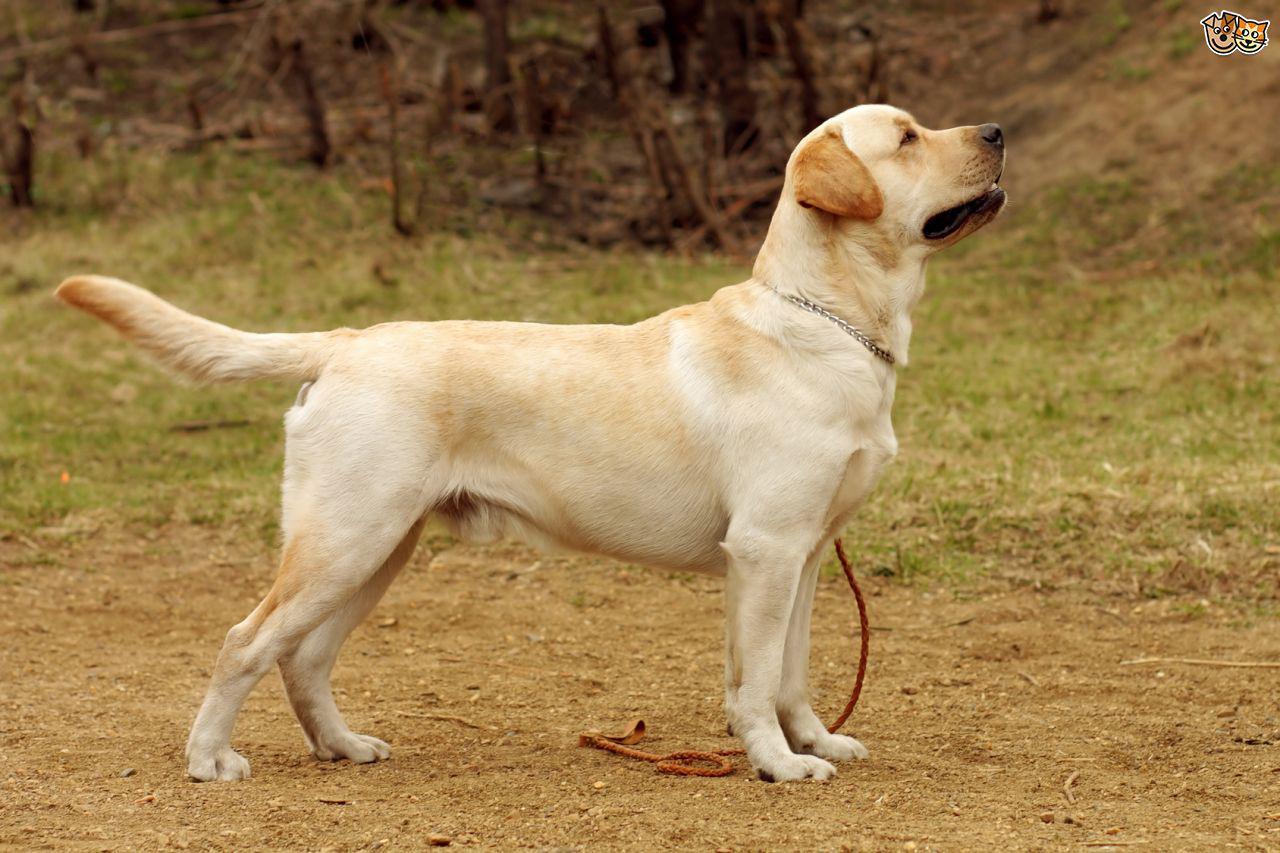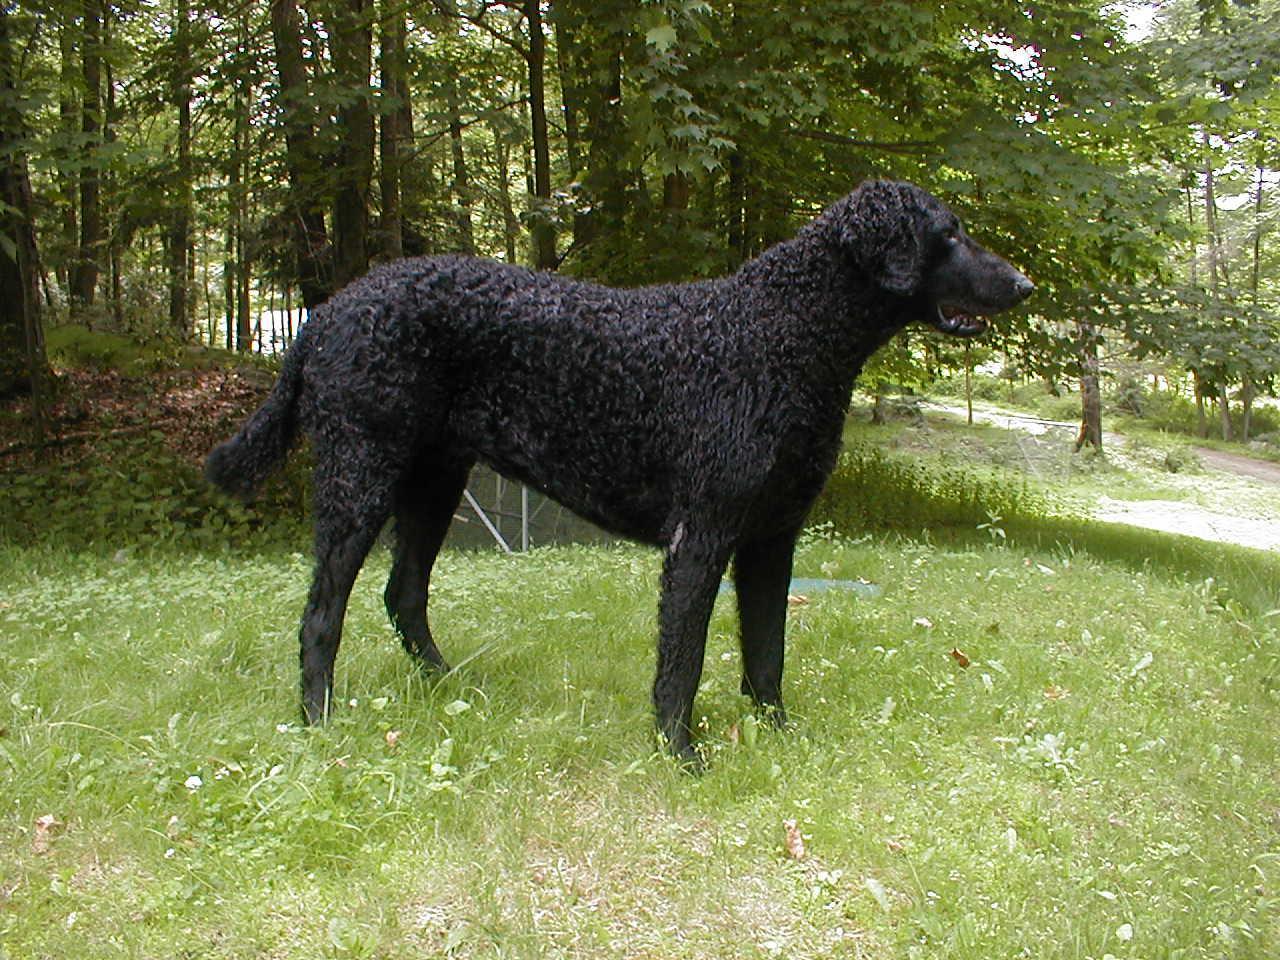The first image is the image on the left, the second image is the image on the right. For the images shown, is this caption "In one of the images there is a single yellow lab standing on all fours on the ground outside." true? Answer yes or no. Yes. 